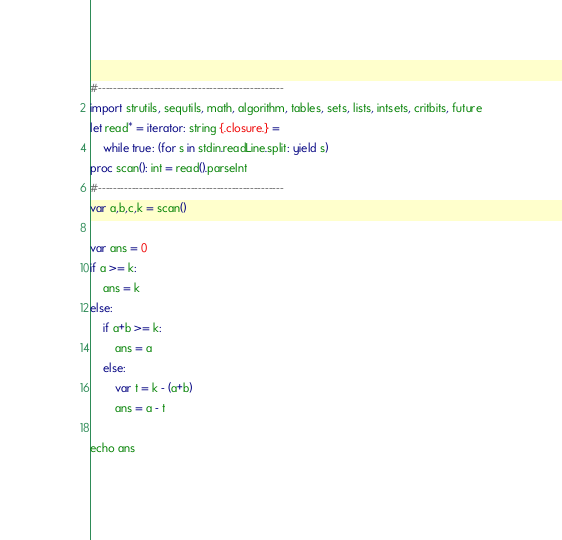<code> <loc_0><loc_0><loc_500><loc_500><_Nim_>#--------------------------------------------------
import strutils, sequtils, math, algorithm, tables, sets, lists, intsets, critbits, future
let read* = iterator: string {.closure.} =
    while true: (for s in stdin.readLine.split: yield s)
proc scan(): int = read().parseInt
#--------------------------------------------------
var a,b,c,k = scan()

var ans = 0
if a >= k:
    ans = k
else:
    if a+b >= k:
        ans = a
    else:
        var t = k - (a+b)
        ans = a - t

echo ans</code> 